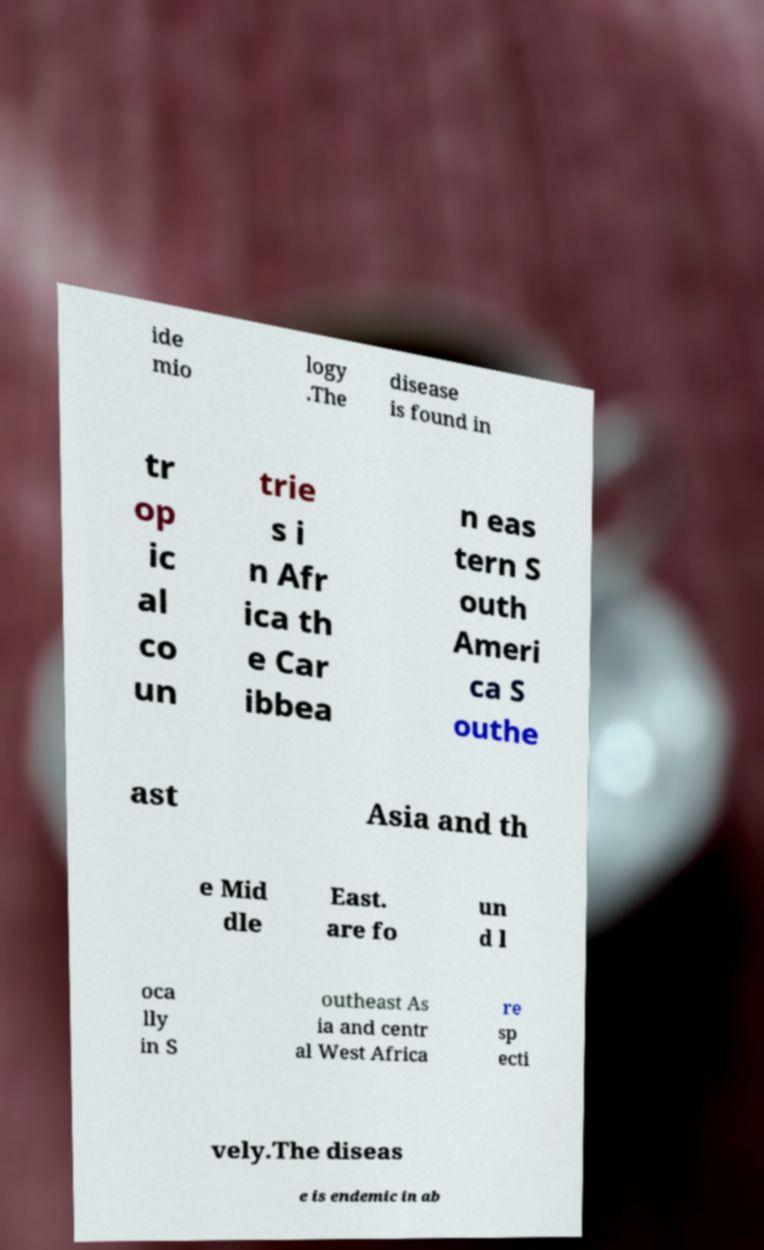For documentation purposes, I need the text within this image transcribed. Could you provide that? ide mio logy .The disease is found in tr op ic al co un trie s i n Afr ica th e Car ibbea n eas tern S outh Ameri ca S outhe ast Asia and th e Mid dle East. are fo un d l oca lly in S outheast As ia and centr al West Africa re sp ecti vely.The diseas e is endemic in ab 